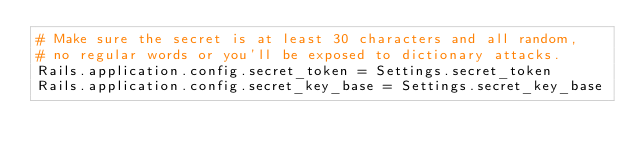Convert code to text. <code><loc_0><loc_0><loc_500><loc_500><_Ruby_># Make sure the secret is at least 30 characters and all random,
# no regular words or you'll be exposed to dictionary attacks.
Rails.application.config.secret_token = Settings.secret_token
Rails.application.config.secret_key_base = Settings.secret_key_base</code> 